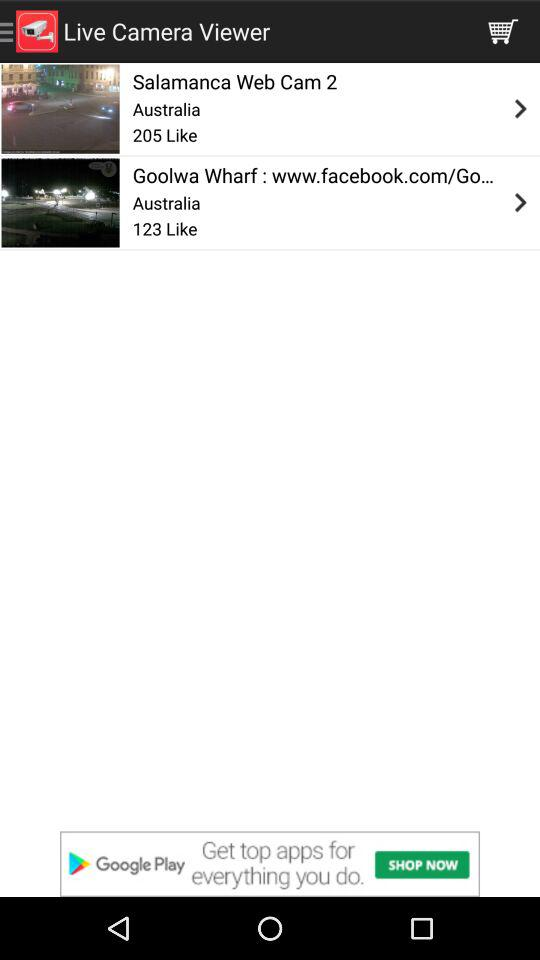What is the number of likes on the camera "Goolwa Wharf"? There are 123 likes. 